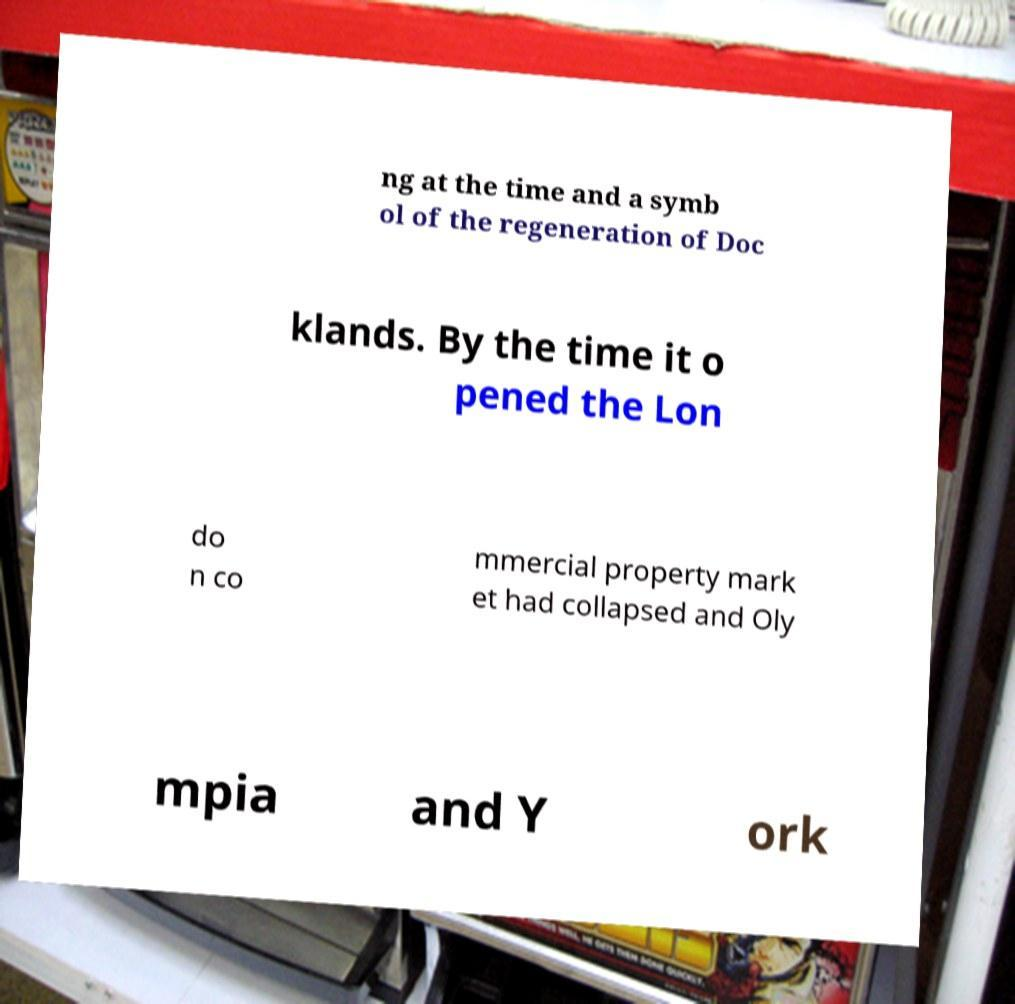I need the written content from this picture converted into text. Can you do that? ng at the time and a symb ol of the regeneration of Doc klands. By the time it o pened the Lon do n co mmercial property mark et had collapsed and Oly mpia and Y ork 